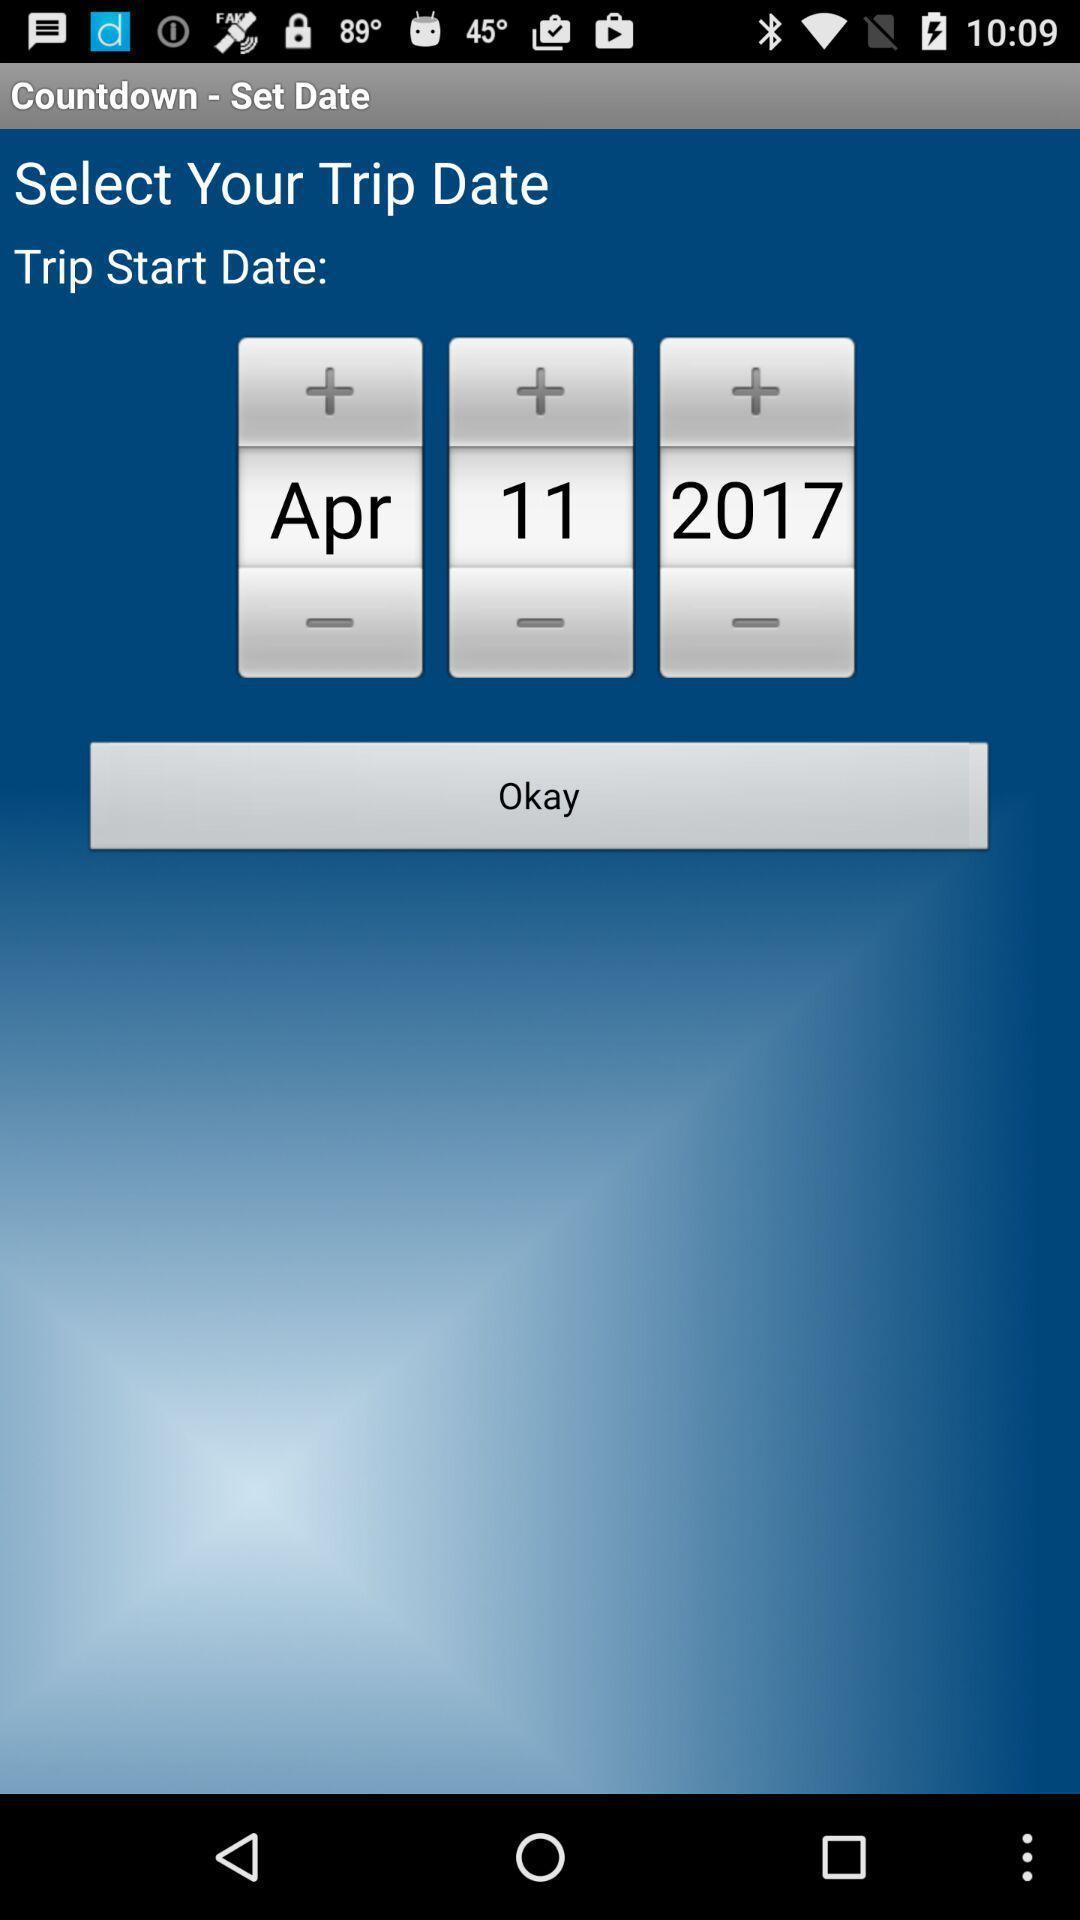Provide a detailed account of this screenshot. Page to set a date for trip. 